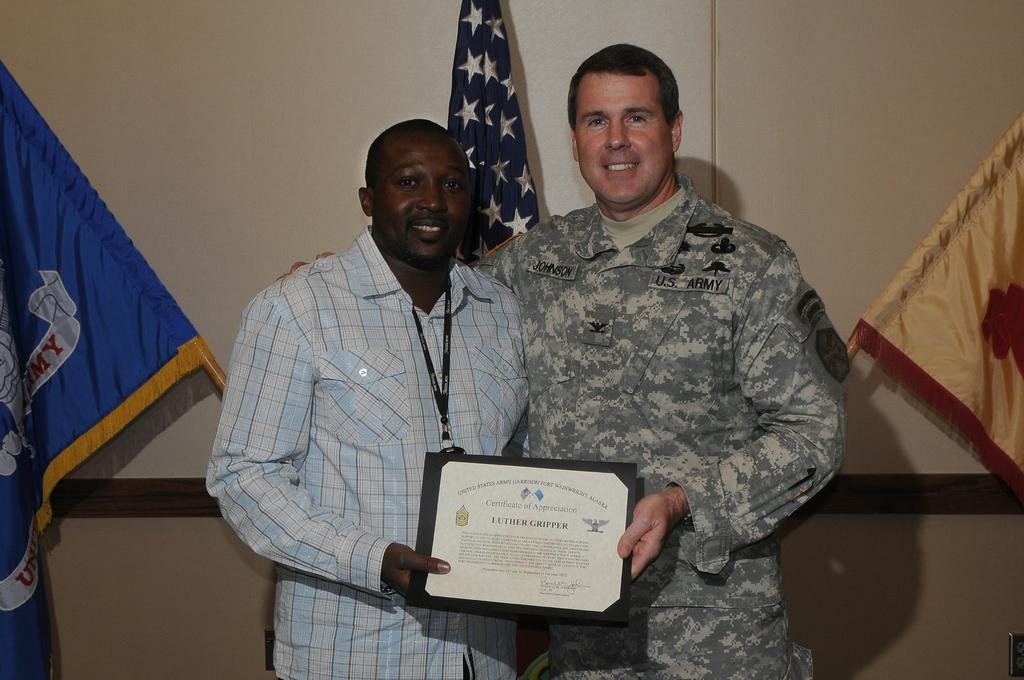How would you summarize this image in a sentence or two? In this image we can see two people standing and holding a memorandum. The man standing on the right is wearing a uniform. In the background there are flags and a wall. 